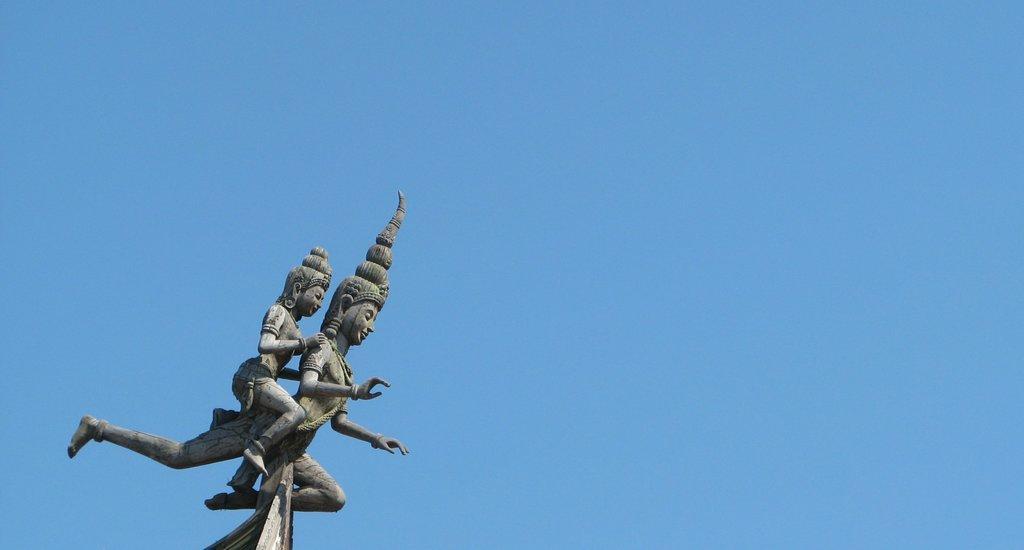Please provide a concise description of this image. In this image there are two sculptures. In the background there is sky. 